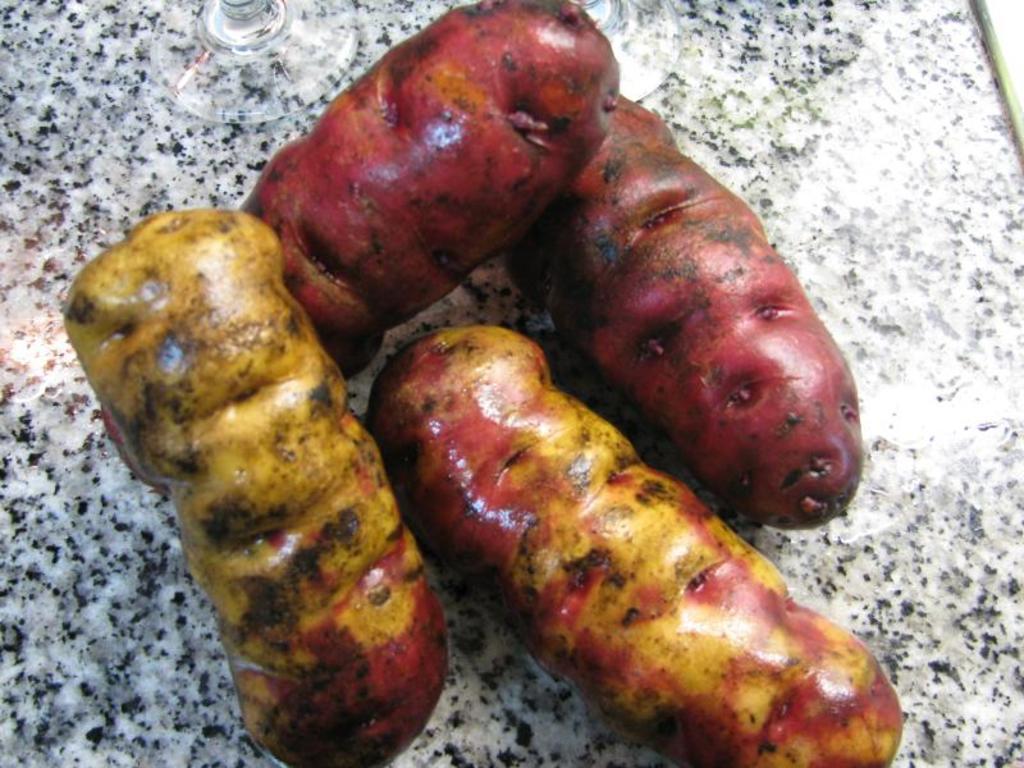Please provide a concise description of this image. This image consists of food. 